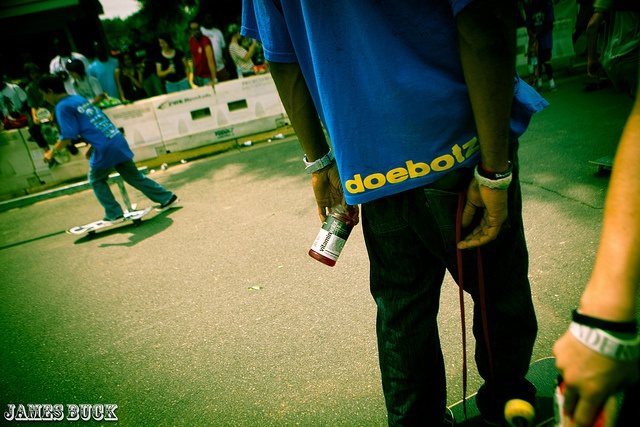Describe the objects in this image and their specific colors. I can see people in black, navy, blue, and darkblue tones, people in black, darkgreen, and tan tones, people in black, orange, and olive tones, people in black, navy, darkgreen, and teal tones, and bottle in black, white, maroon, and darkgreen tones in this image. 